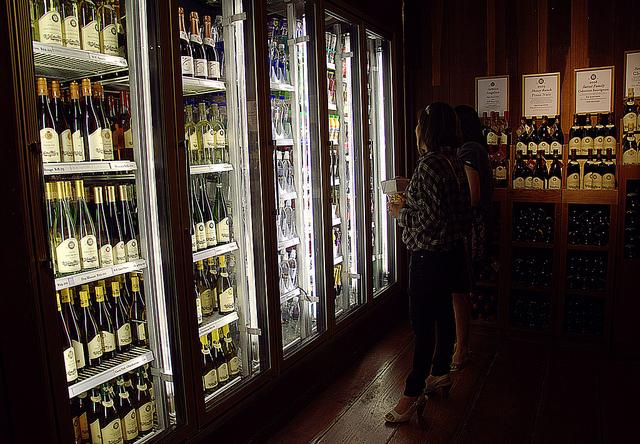Where are these two girls at? Please explain your reasoning. liquor store. This is obvious based on all of the alcohol bottles. 